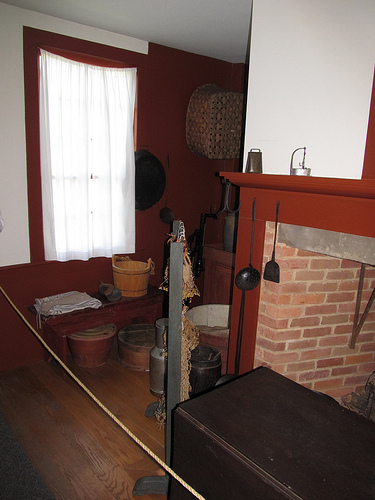What is the large brown object in the foreground? The large brown object in the foreground looks to be an antique trunk or a vintage wooden box. It serves as both a decorative element and possibly a storage piece, adding to the room's rustic and historical theme. 